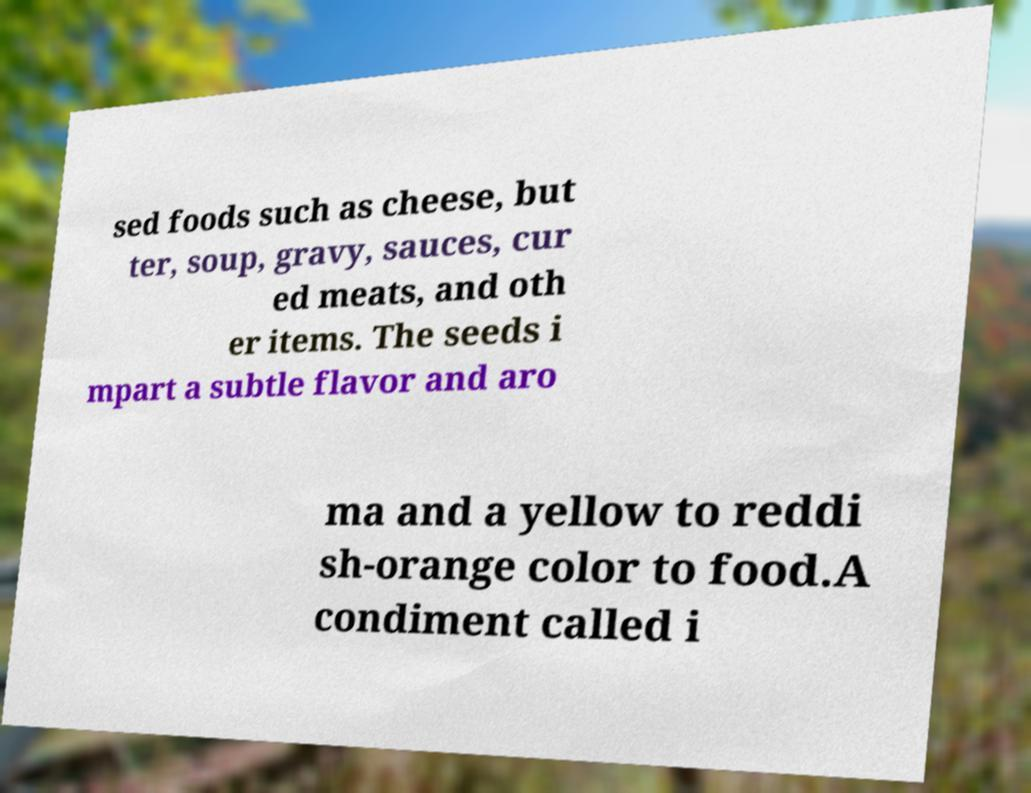Could you extract and type out the text from this image? sed foods such as cheese, but ter, soup, gravy, sauces, cur ed meats, and oth er items. The seeds i mpart a subtle flavor and aro ma and a yellow to reddi sh-orange color to food.A condiment called i 